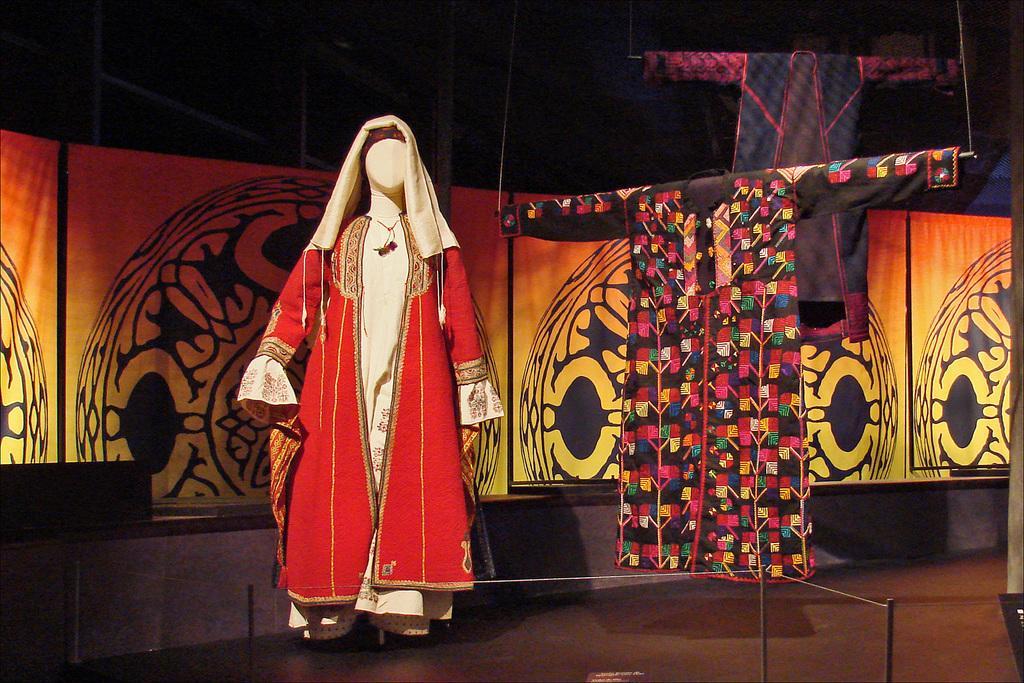Could you give a brief overview of what you see in this image? In this picture I can observe a mannequin. There is red color dress on the mannequin. On the right side there are some dresses hanged. Behind the dresser there is an orange and yellow color wall. The background is dark. 